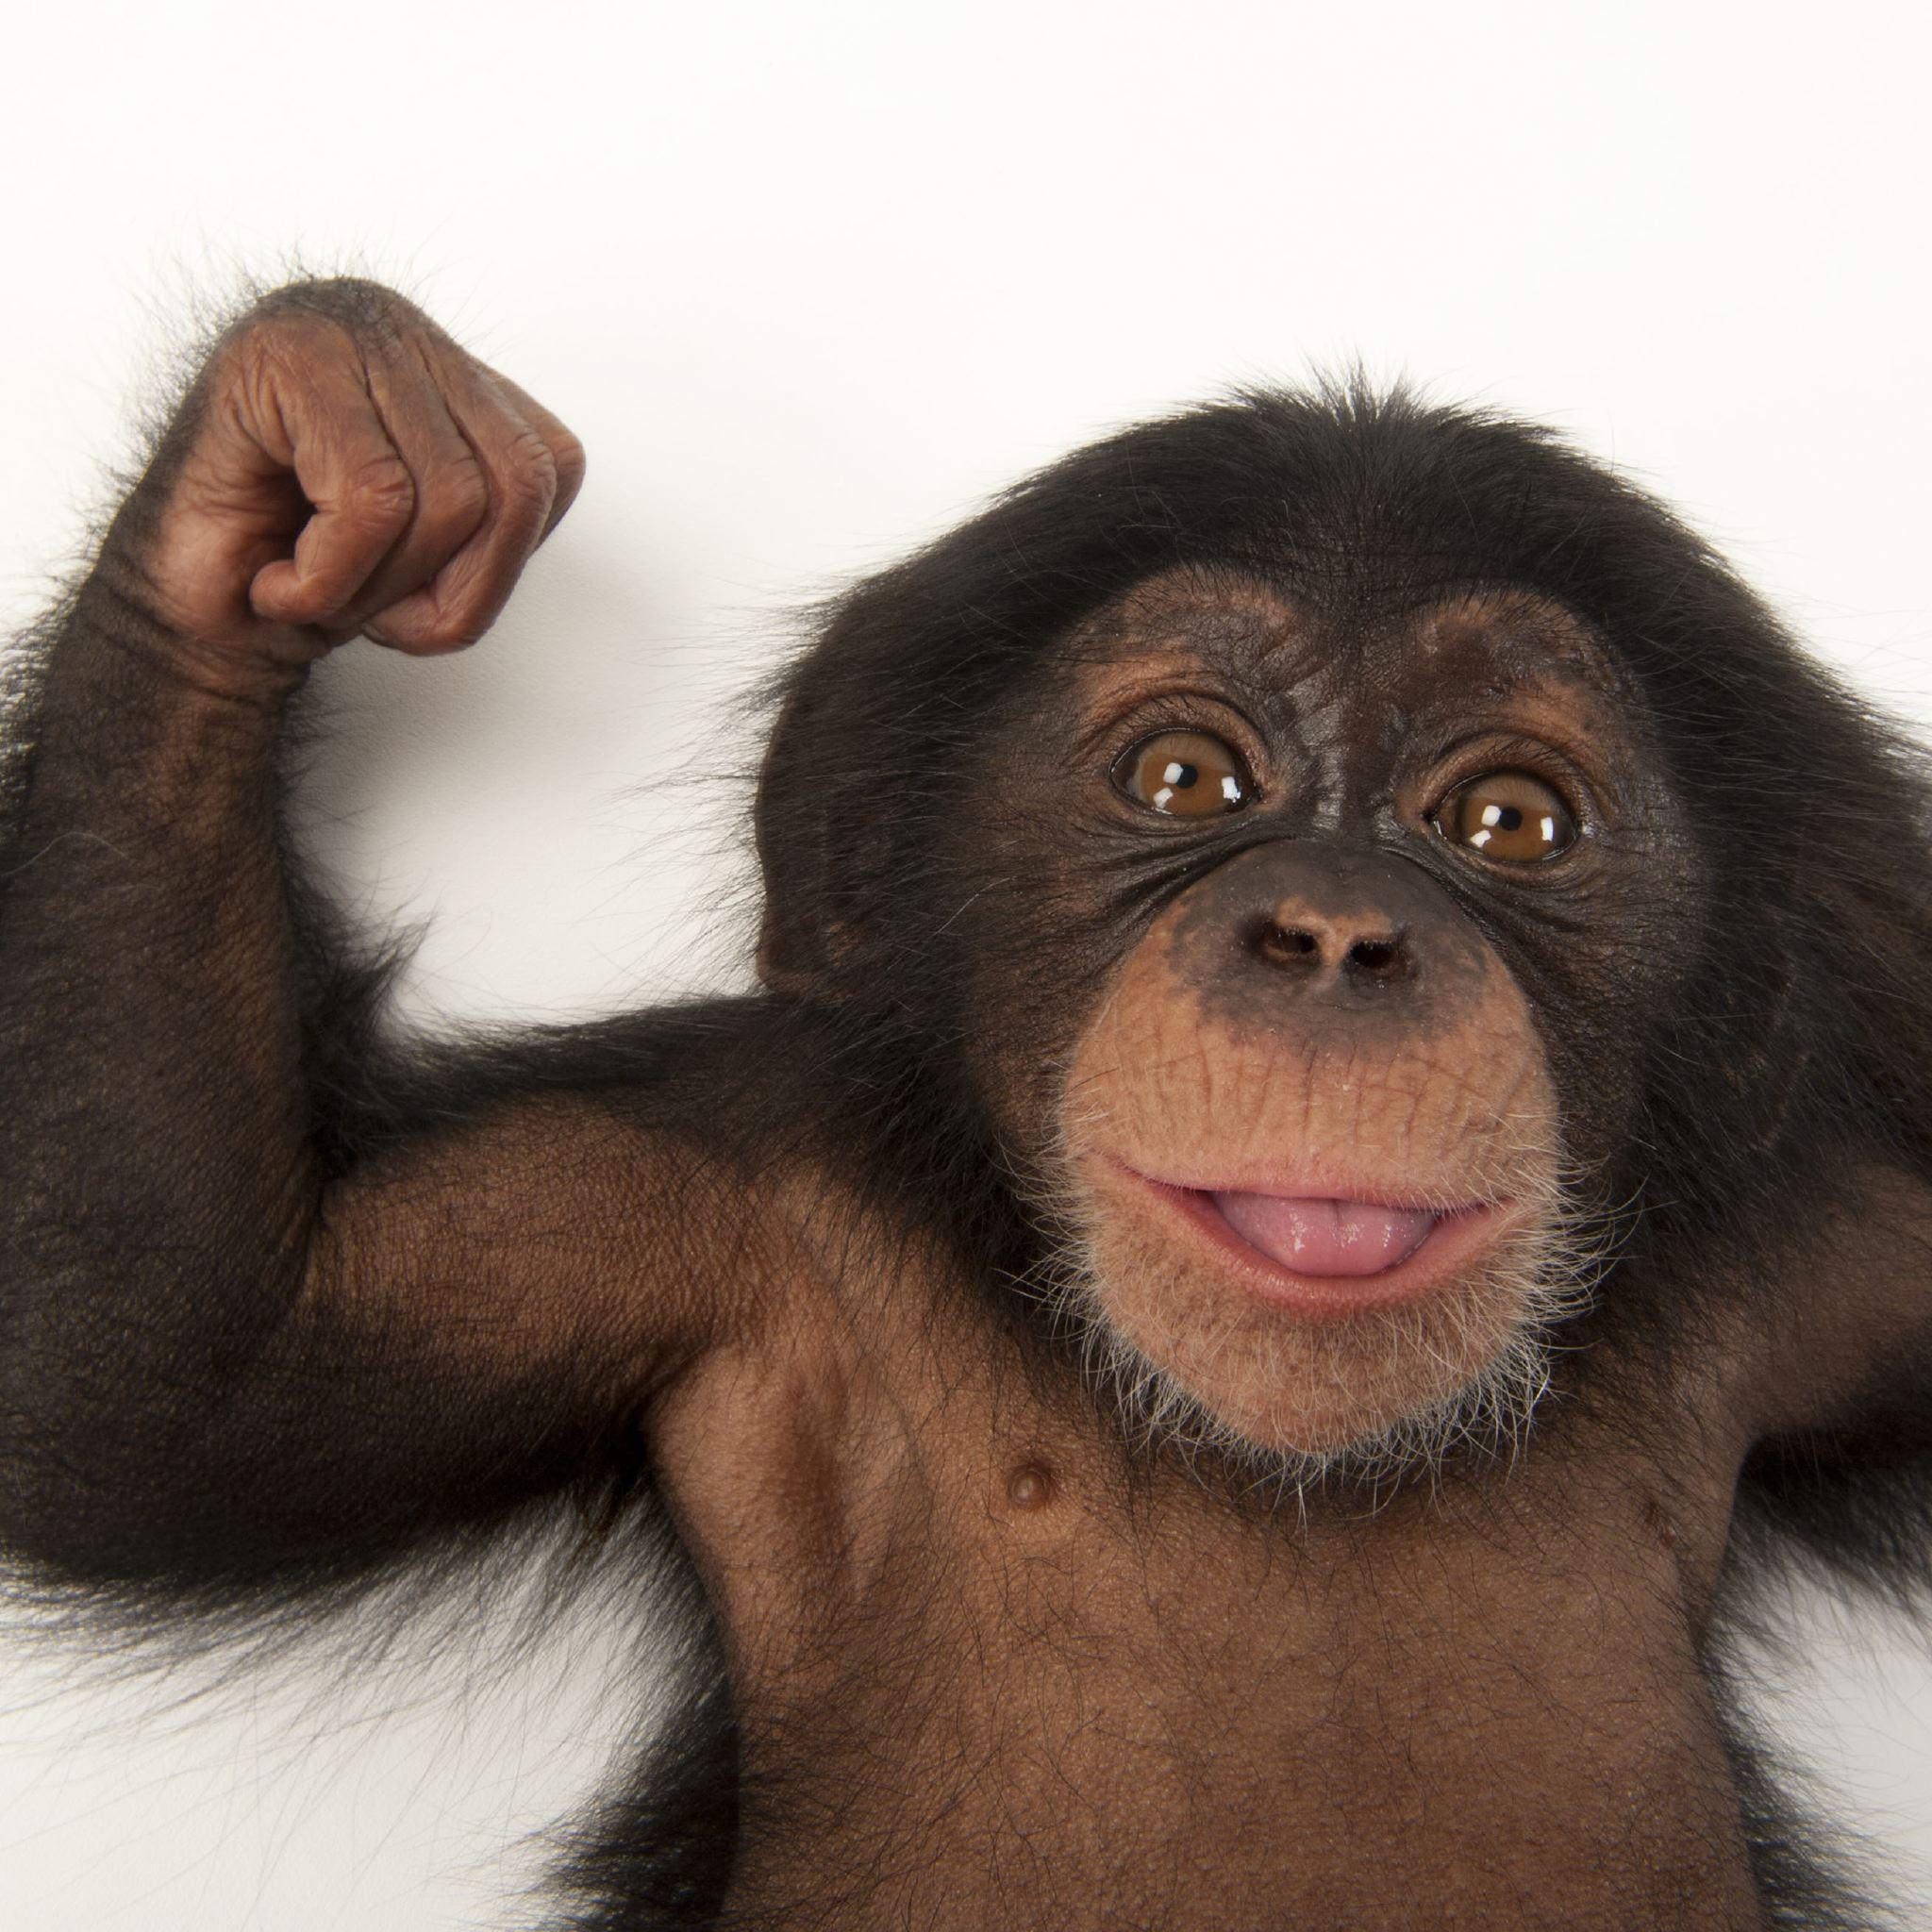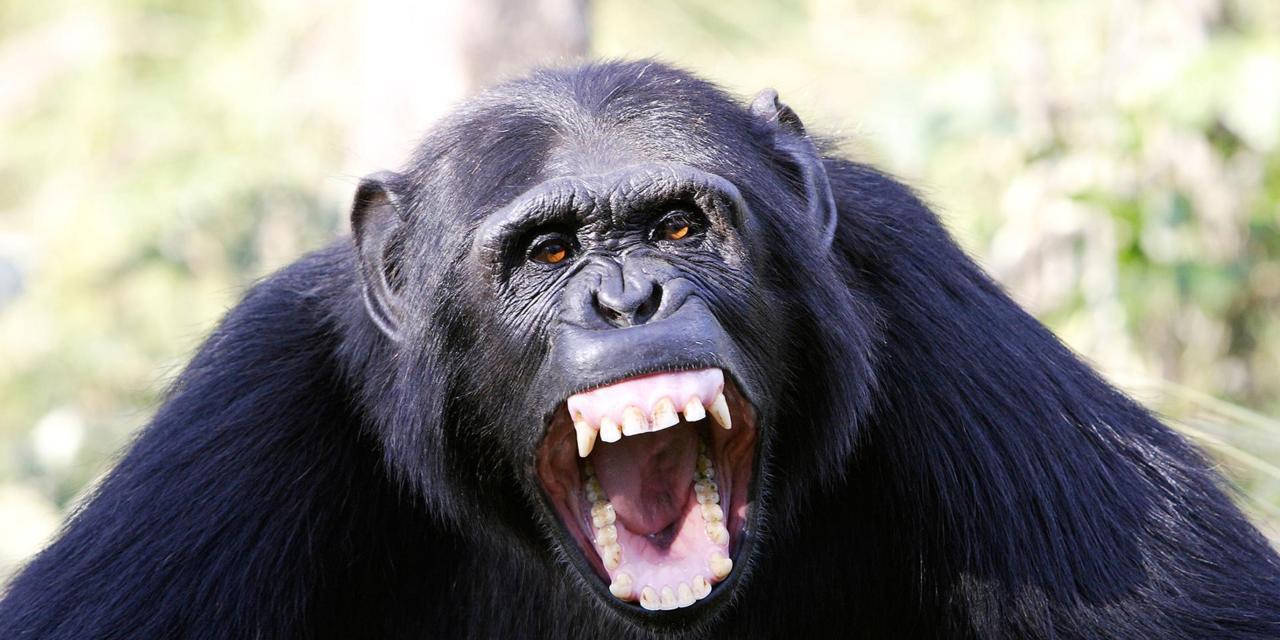The first image is the image on the left, the second image is the image on the right. Considering the images on both sides, is "The is one monkey in the image on the right." valid? Answer yes or no. Yes. 